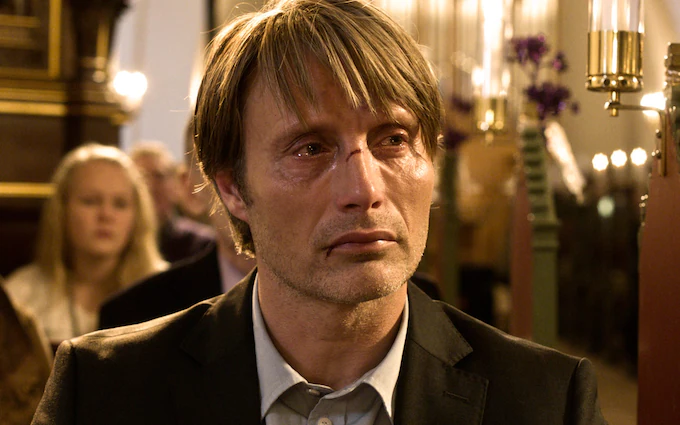Explain the visual content of the image in great detail. The image features a man with a recognizable face that suggests he might be an actor. He is standing in a church, seemingly lost in thought as he directs his gaze to the side. His emotions are palpable, with tears welling up in his eyes. His clothing is formal, featuring a black suit and a disheveled hairstyle that contrasts with his otherwise polished appearance. The backdrop of the image, although slightly blurred, depicts the grandeur of a church interior. In the background, figures of other people are visible, as well as parts of a large pipe organ and decorative elements that enhance the ambiance of the setting. 